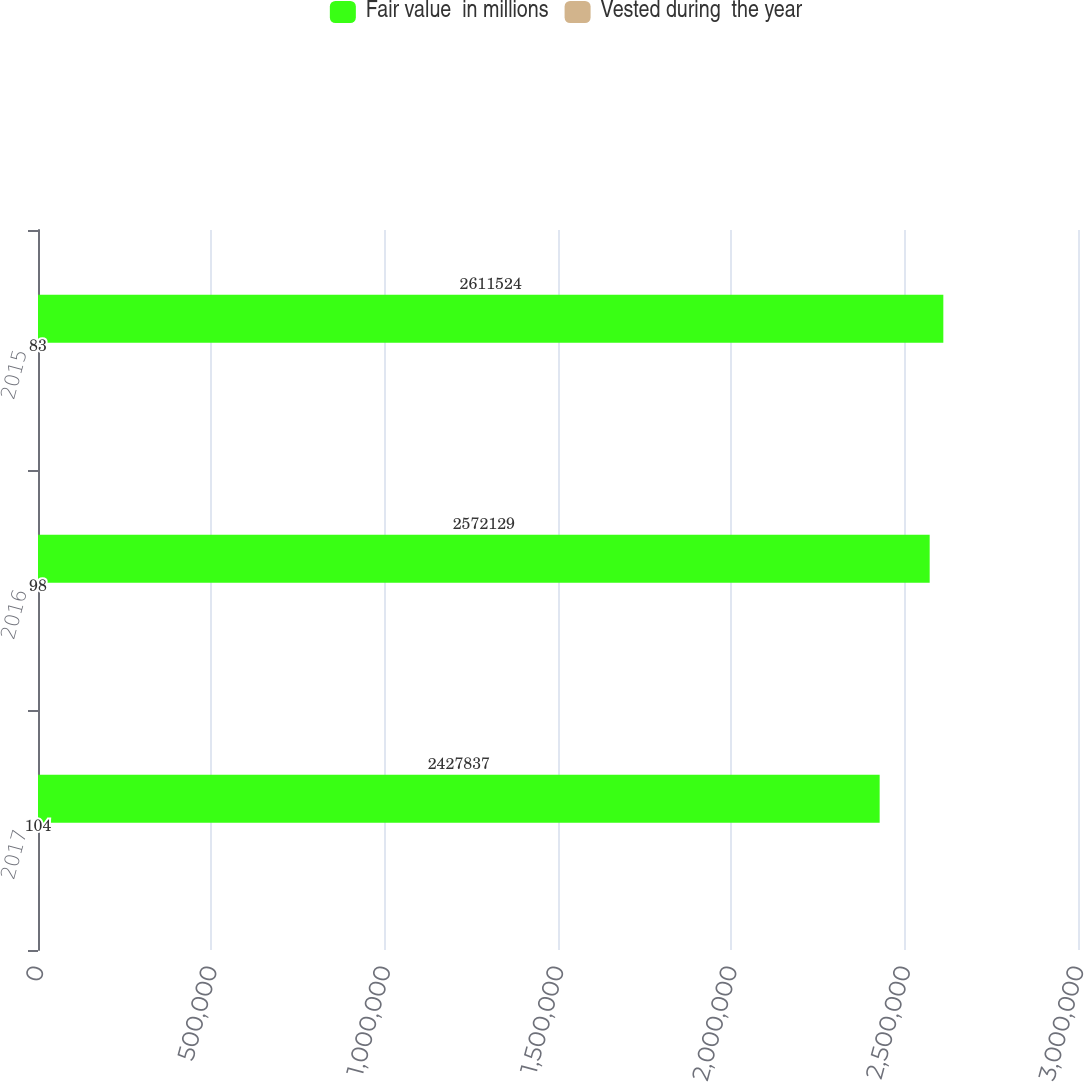Convert chart. <chart><loc_0><loc_0><loc_500><loc_500><stacked_bar_chart><ecel><fcel>2017<fcel>2016<fcel>2015<nl><fcel>Fair value  in millions<fcel>2.42784e+06<fcel>2.57213e+06<fcel>2.61152e+06<nl><fcel>Vested during  the year<fcel>104<fcel>98<fcel>83<nl></chart> 